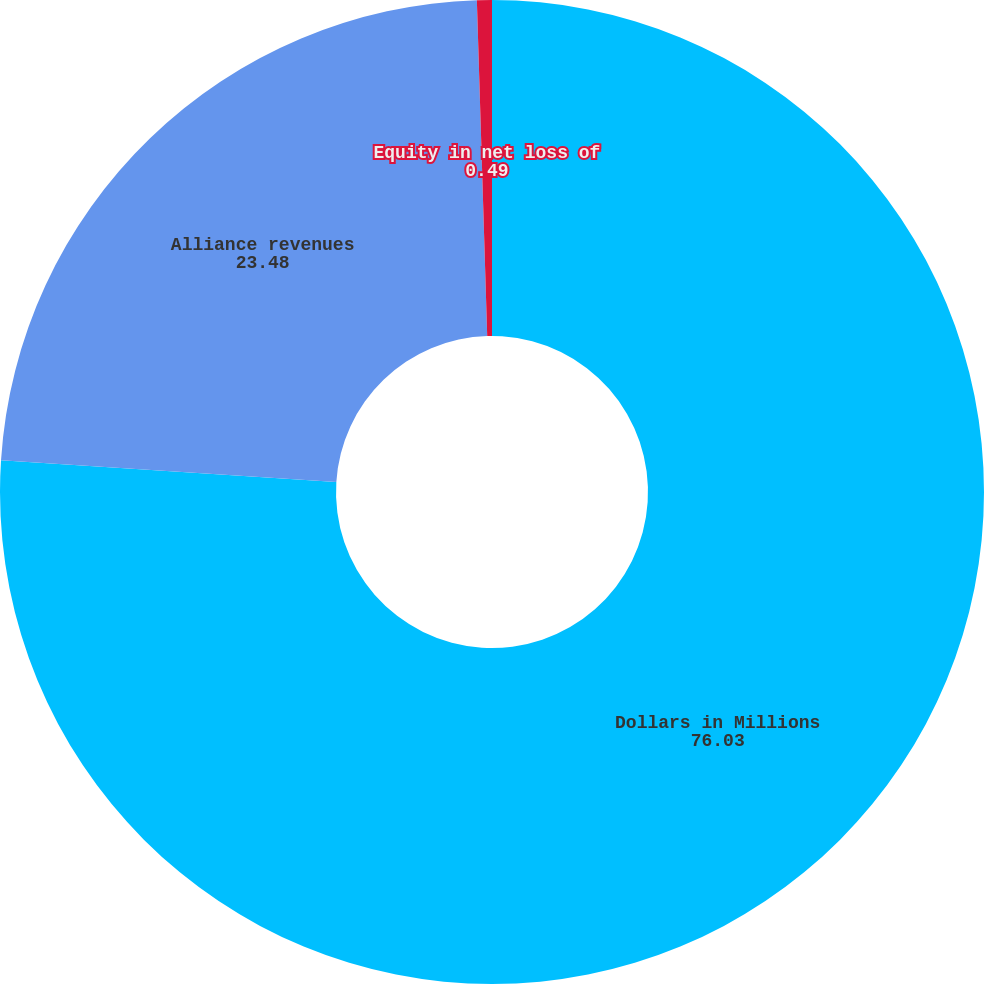Convert chart to OTSL. <chart><loc_0><loc_0><loc_500><loc_500><pie_chart><fcel>Dollars in Millions<fcel>Alliance revenues<fcel>Equity in net loss of<nl><fcel>76.03%<fcel>23.48%<fcel>0.49%<nl></chart> 